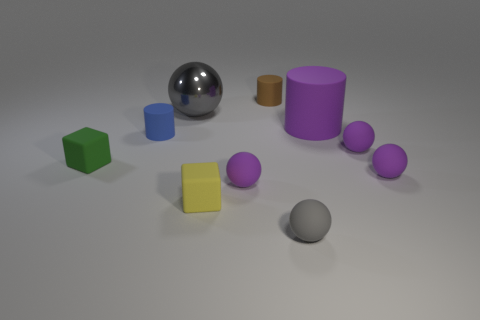Subtract all gray cubes. How many purple balls are left? 3 Subtract 3 spheres. How many spheres are left? 2 Subtract all tiny gray balls. How many balls are left? 4 Subtract all green balls. Subtract all red cylinders. How many balls are left? 5 Subtract all cubes. How many objects are left? 8 Subtract 0 blue spheres. How many objects are left? 10 Subtract all large purple rubber cylinders. Subtract all big purple cylinders. How many objects are left? 8 Add 7 small brown objects. How many small brown objects are left? 8 Add 4 small yellow matte objects. How many small yellow matte objects exist? 5 